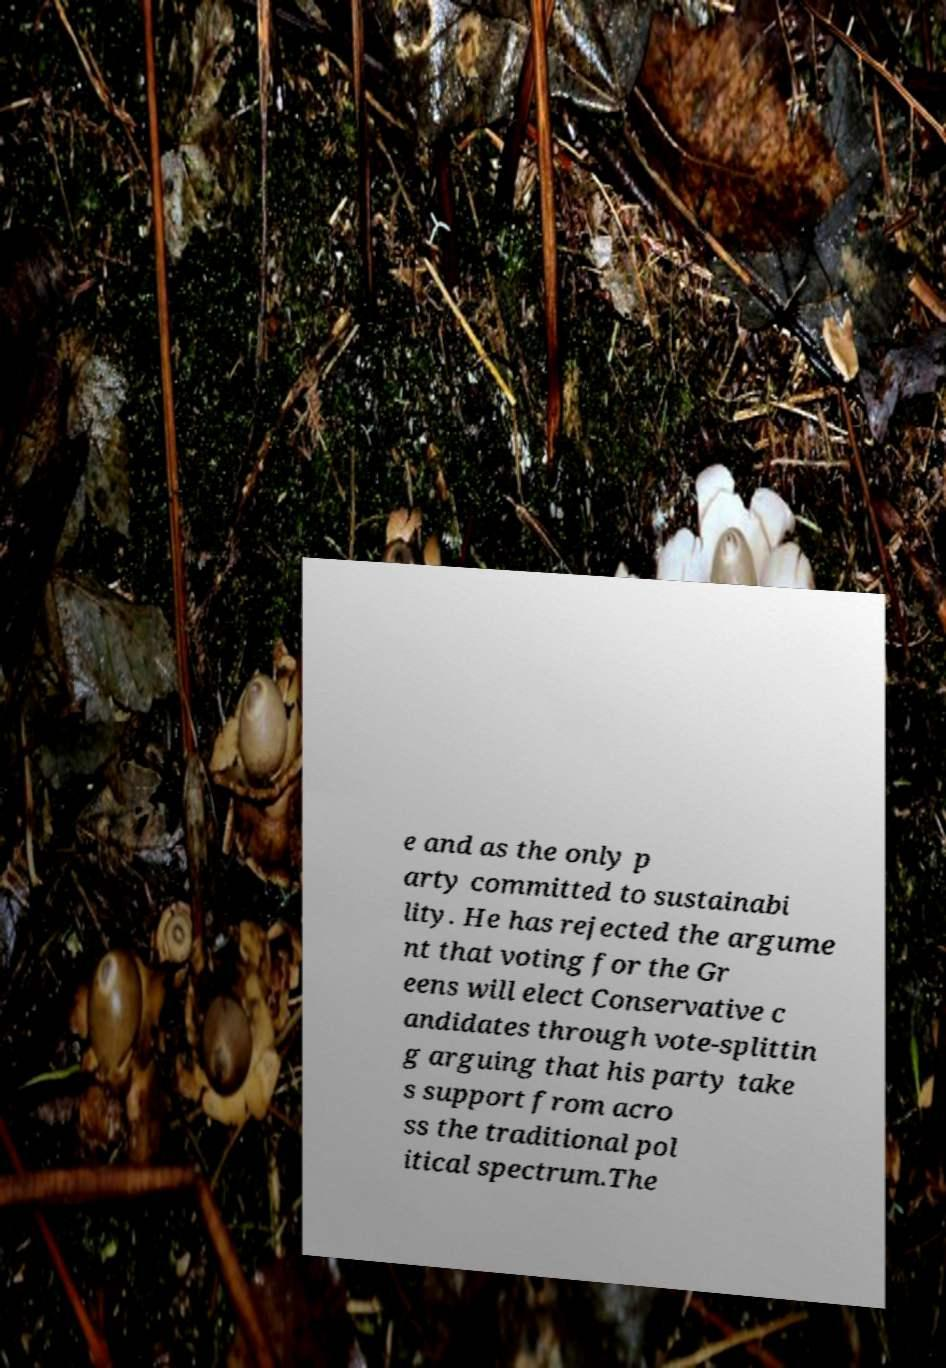Please identify and transcribe the text found in this image. e and as the only p arty committed to sustainabi lity. He has rejected the argume nt that voting for the Gr eens will elect Conservative c andidates through vote-splittin g arguing that his party take s support from acro ss the traditional pol itical spectrum.The 